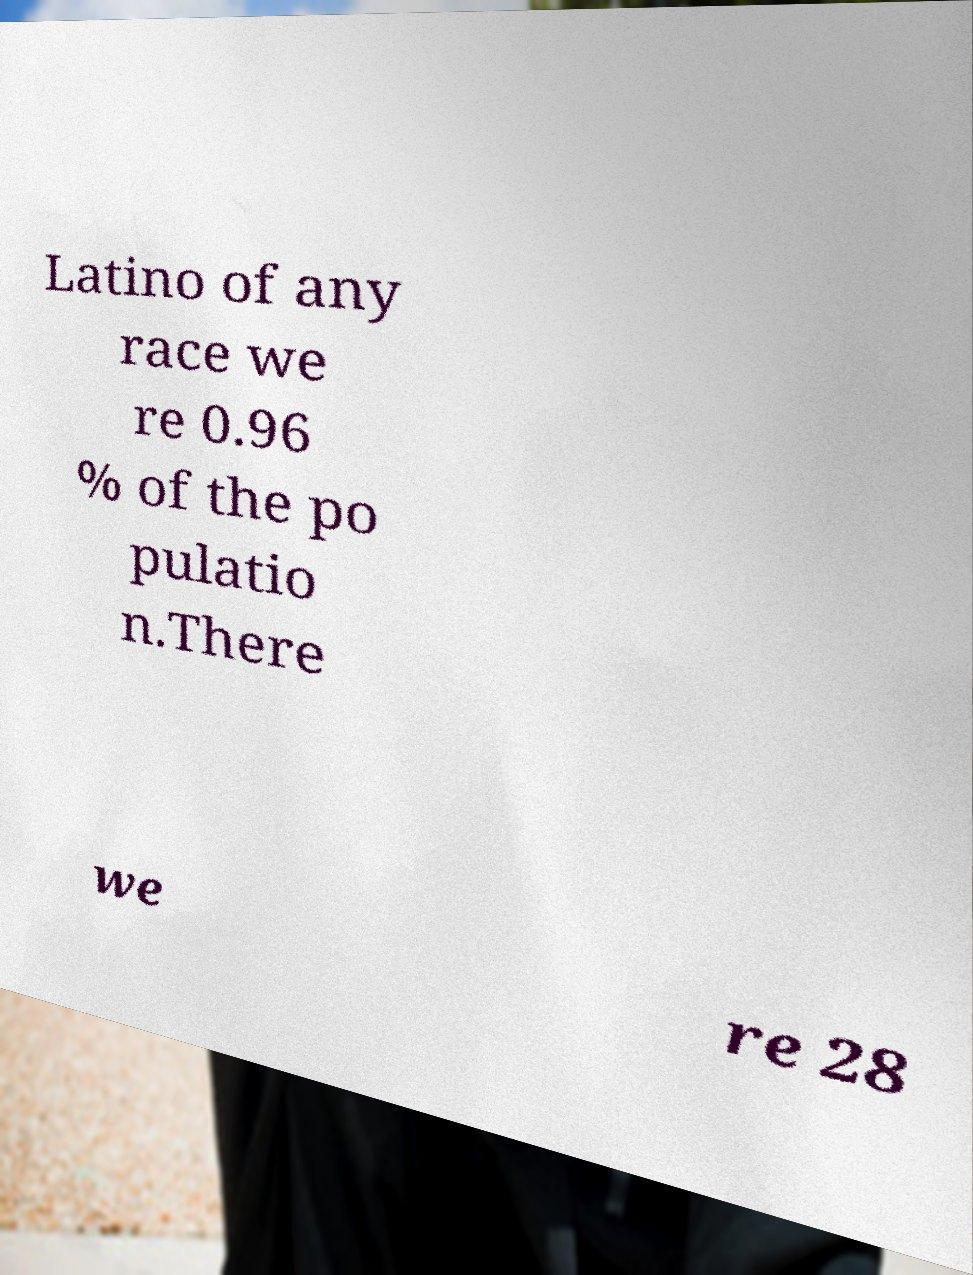Can you accurately transcribe the text from the provided image for me? Latino of any race we re 0.96 % of the po pulatio n.There we re 28 